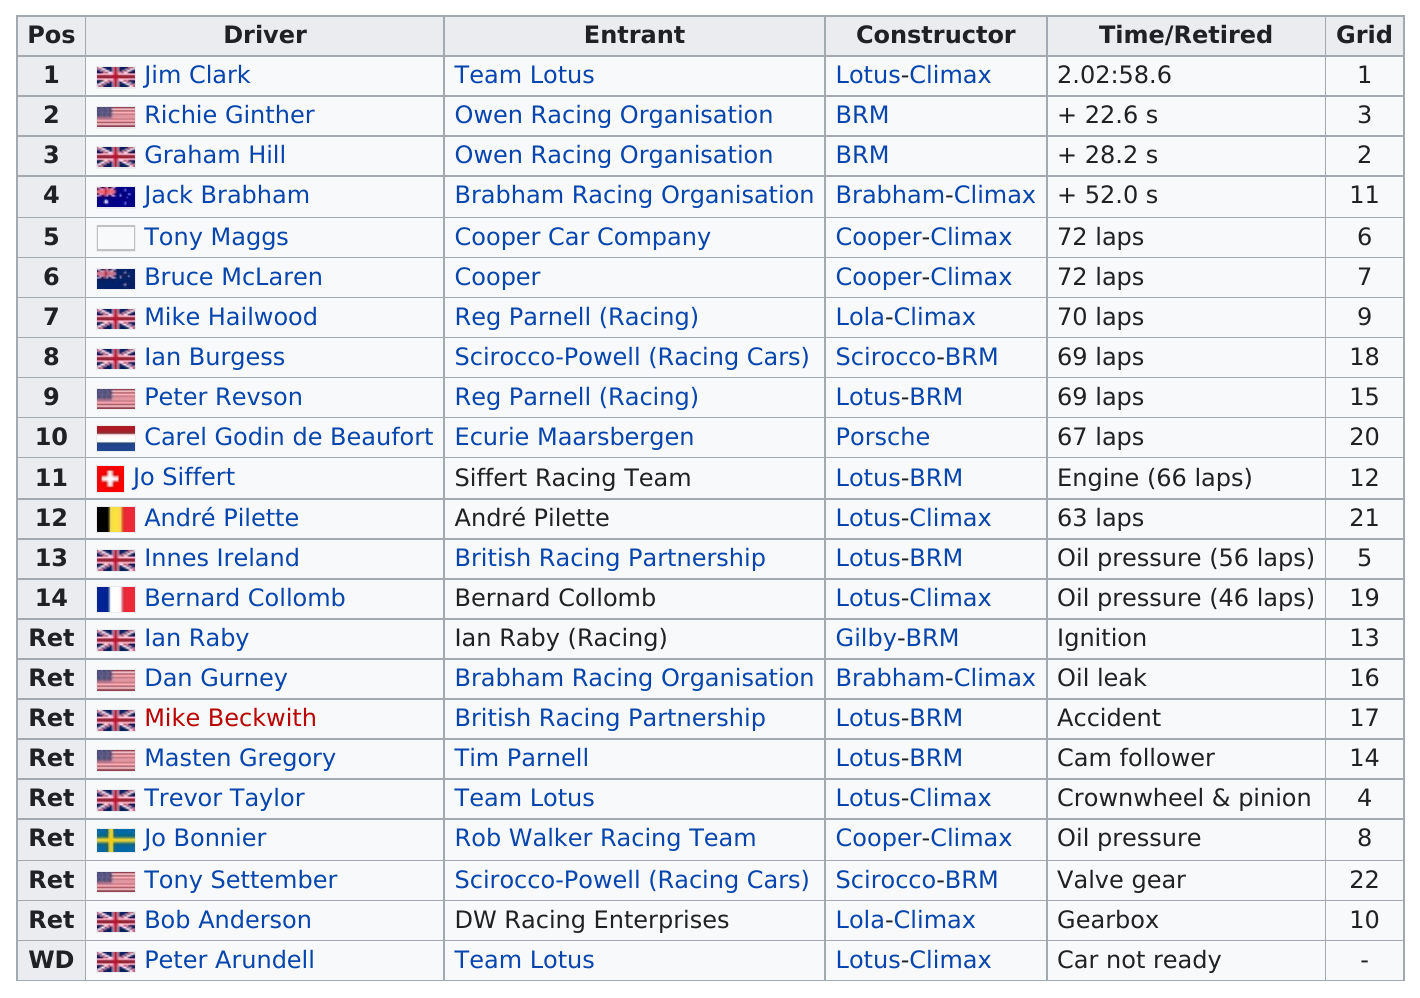Highlight a few significant elements in this photo. Jim Clark was the top competitor in the race. The report lists 23 unique drivers. Tony Maggs, the top finisher, drove a Cooper-Climax. Peter Arundell, the driver, did not have his/her car ready. Jim Clark came in first. 